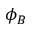<formula> <loc_0><loc_0><loc_500><loc_500>\phi _ { B }</formula> 